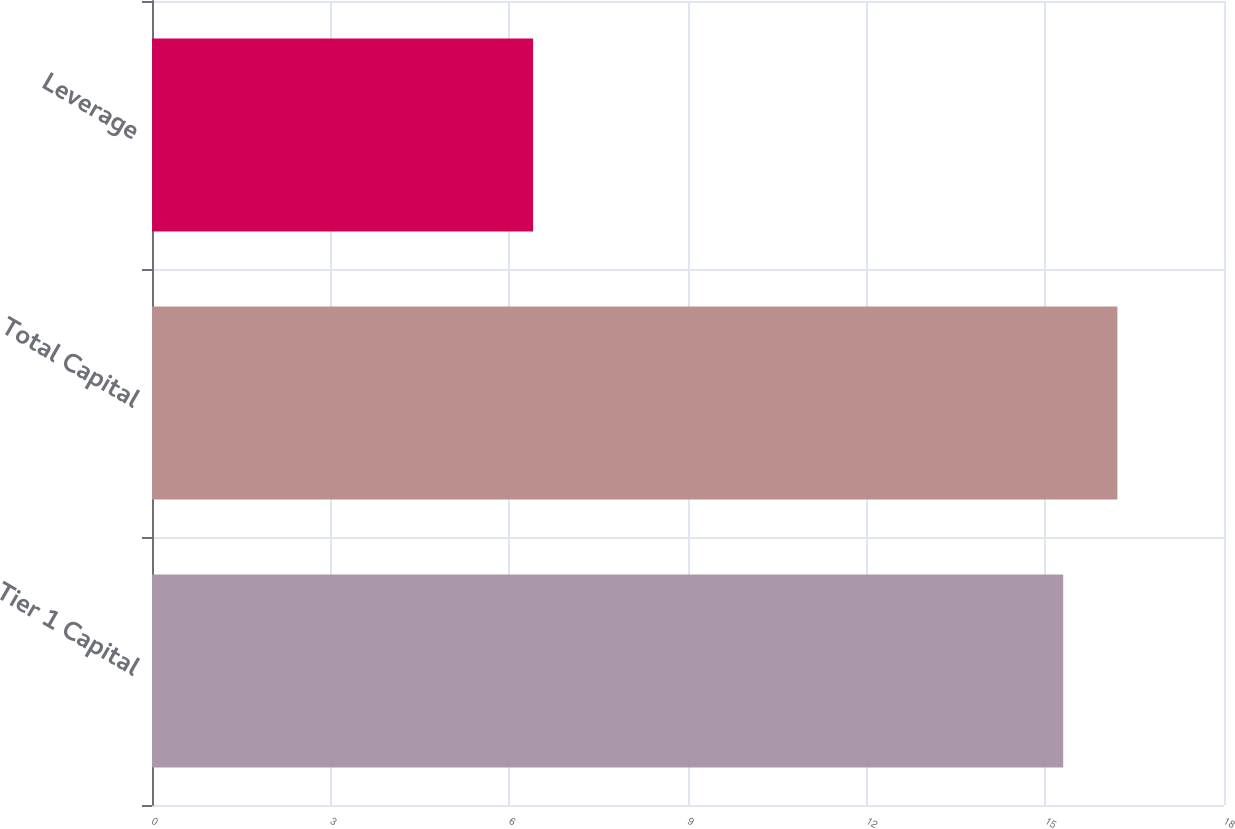<chart> <loc_0><loc_0><loc_500><loc_500><bar_chart><fcel>Tier 1 Capital<fcel>Total Capital<fcel>Leverage<nl><fcel>15.3<fcel>16.21<fcel>6.4<nl></chart> 